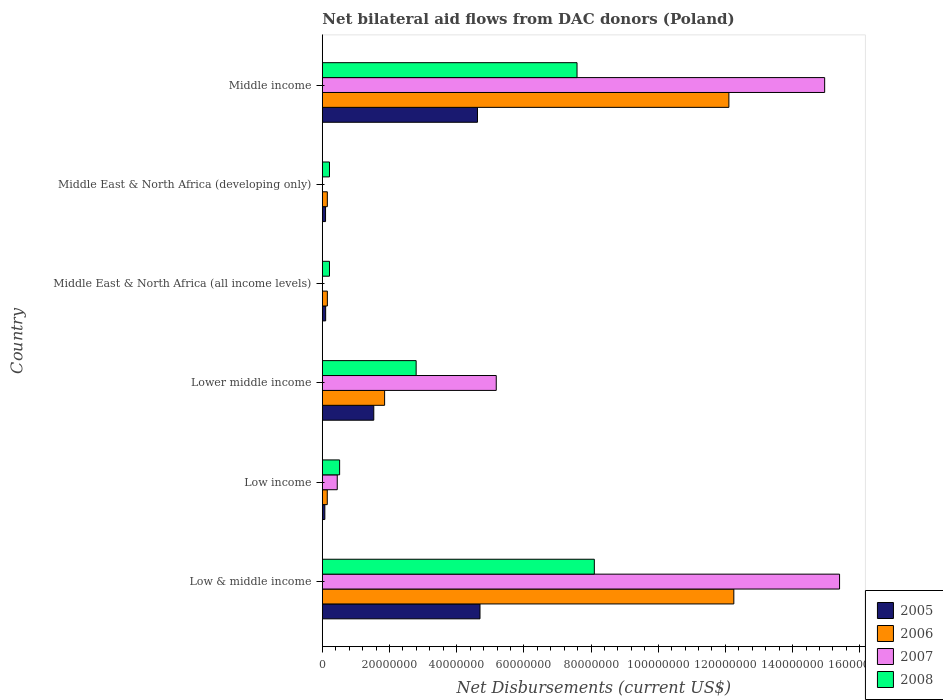How many bars are there on the 2nd tick from the top?
Provide a succinct answer. 3. In how many cases, is the number of bars for a given country not equal to the number of legend labels?
Offer a very short reply. 2. What is the net bilateral aid flows in 2005 in Low income?
Provide a short and direct response. 7.50e+05. Across all countries, what is the maximum net bilateral aid flows in 2008?
Offer a terse response. 8.10e+07. Across all countries, what is the minimum net bilateral aid flows in 2005?
Offer a terse response. 7.50e+05. What is the total net bilateral aid flows in 2008 in the graph?
Make the answer very short. 1.94e+08. What is the difference between the net bilateral aid flows in 2006 in Low income and that in Middle income?
Keep it short and to the point. -1.20e+08. What is the difference between the net bilateral aid flows in 2005 in Middle income and the net bilateral aid flows in 2006 in Low & middle income?
Provide a short and direct response. -7.63e+07. What is the average net bilateral aid flows in 2005 per country?
Provide a succinct answer. 1.85e+07. What is the difference between the net bilateral aid flows in 2008 and net bilateral aid flows in 2007 in Middle income?
Provide a short and direct response. -7.37e+07. What is the ratio of the net bilateral aid flows in 2008 in Low income to that in Middle East & North Africa (all income levels)?
Your answer should be very brief. 2.42. Is the net bilateral aid flows in 2005 in Low & middle income less than that in Low income?
Give a very brief answer. No. Is the difference between the net bilateral aid flows in 2008 in Low & middle income and Middle income greater than the difference between the net bilateral aid flows in 2007 in Low & middle income and Middle income?
Make the answer very short. Yes. What is the difference between the highest and the second highest net bilateral aid flows in 2008?
Give a very brief answer. 5.15e+06. What is the difference between the highest and the lowest net bilateral aid flows in 2008?
Give a very brief answer. 7.88e+07. Is the sum of the net bilateral aid flows in 2005 in Lower middle income and Middle East & North Africa (developing only) greater than the maximum net bilateral aid flows in 2007 across all countries?
Keep it short and to the point. No. Is it the case that in every country, the sum of the net bilateral aid flows in 2008 and net bilateral aid flows in 2007 is greater than the sum of net bilateral aid flows in 2006 and net bilateral aid flows in 2005?
Keep it short and to the point. No. Is it the case that in every country, the sum of the net bilateral aid flows in 2007 and net bilateral aid flows in 2005 is greater than the net bilateral aid flows in 2006?
Make the answer very short. No. How many bars are there?
Your answer should be very brief. 22. Are all the bars in the graph horizontal?
Ensure brevity in your answer.  Yes. How are the legend labels stacked?
Ensure brevity in your answer.  Vertical. What is the title of the graph?
Offer a very short reply. Net bilateral aid flows from DAC donors (Poland). What is the label or title of the X-axis?
Your answer should be compact. Net Disbursements (current US$). What is the label or title of the Y-axis?
Make the answer very short. Country. What is the Net Disbursements (current US$) in 2005 in Low & middle income?
Keep it short and to the point. 4.69e+07. What is the Net Disbursements (current US$) in 2006 in Low & middle income?
Your response must be concise. 1.23e+08. What is the Net Disbursements (current US$) of 2007 in Low & middle income?
Your response must be concise. 1.54e+08. What is the Net Disbursements (current US$) of 2008 in Low & middle income?
Offer a very short reply. 8.10e+07. What is the Net Disbursements (current US$) in 2005 in Low income?
Make the answer very short. 7.50e+05. What is the Net Disbursements (current US$) in 2006 in Low income?
Make the answer very short. 1.47e+06. What is the Net Disbursements (current US$) in 2007 in Low income?
Offer a very short reply. 4.44e+06. What is the Net Disbursements (current US$) in 2008 in Low income?
Offer a terse response. 5.15e+06. What is the Net Disbursements (current US$) in 2005 in Lower middle income?
Provide a succinct answer. 1.53e+07. What is the Net Disbursements (current US$) in 2006 in Lower middle income?
Offer a very short reply. 1.85e+07. What is the Net Disbursements (current US$) of 2007 in Lower middle income?
Ensure brevity in your answer.  5.18e+07. What is the Net Disbursements (current US$) in 2008 in Lower middle income?
Your answer should be compact. 2.79e+07. What is the Net Disbursements (current US$) of 2005 in Middle East & North Africa (all income levels)?
Make the answer very short. 9.90e+05. What is the Net Disbursements (current US$) in 2006 in Middle East & North Africa (all income levels)?
Make the answer very short. 1.50e+06. What is the Net Disbursements (current US$) in 2007 in Middle East & North Africa (all income levels)?
Your answer should be very brief. 0. What is the Net Disbursements (current US$) of 2008 in Middle East & North Africa (all income levels)?
Your answer should be compact. 2.13e+06. What is the Net Disbursements (current US$) in 2005 in Middle East & North Africa (developing only)?
Keep it short and to the point. 9.60e+05. What is the Net Disbursements (current US$) in 2006 in Middle East & North Africa (developing only)?
Give a very brief answer. 1.49e+06. What is the Net Disbursements (current US$) in 2008 in Middle East & North Africa (developing only)?
Offer a very short reply. 2.13e+06. What is the Net Disbursements (current US$) of 2005 in Middle income?
Keep it short and to the point. 4.62e+07. What is the Net Disbursements (current US$) in 2006 in Middle income?
Make the answer very short. 1.21e+08. What is the Net Disbursements (current US$) of 2007 in Middle income?
Keep it short and to the point. 1.50e+08. What is the Net Disbursements (current US$) in 2008 in Middle income?
Your answer should be very brief. 7.58e+07. Across all countries, what is the maximum Net Disbursements (current US$) in 2005?
Your response must be concise. 4.69e+07. Across all countries, what is the maximum Net Disbursements (current US$) in 2006?
Give a very brief answer. 1.23e+08. Across all countries, what is the maximum Net Disbursements (current US$) in 2007?
Offer a very short reply. 1.54e+08. Across all countries, what is the maximum Net Disbursements (current US$) of 2008?
Offer a terse response. 8.10e+07. Across all countries, what is the minimum Net Disbursements (current US$) of 2005?
Provide a succinct answer. 7.50e+05. Across all countries, what is the minimum Net Disbursements (current US$) in 2006?
Make the answer very short. 1.47e+06. Across all countries, what is the minimum Net Disbursements (current US$) of 2008?
Your response must be concise. 2.13e+06. What is the total Net Disbursements (current US$) of 2005 in the graph?
Give a very brief answer. 1.11e+08. What is the total Net Disbursements (current US$) in 2006 in the graph?
Your answer should be compact. 2.67e+08. What is the total Net Disbursements (current US$) in 2007 in the graph?
Your answer should be compact. 3.60e+08. What is the total Net Disbursements (current US$) in 2008 in the graph?
Make the answer very short. 1.94e+08. What is the difference between the Net Disbursements (current US$) in 2005 in Low & middle income and that in Low income?
Make the answer very short. 4.62e+07. What is the difference between the Net Disbursements (current US$) of 2006 in Low & middle income and that in Low income?
Ensure brevity in your answer.  1.21e+08. What is the difference between the Net Disbursements (current US$) in 2007 in Low & middle income and that in Low income?
Make the answer very short. 1.50e+08. What is the difference between the Net Disbursements (current US$) in 2008 in Low & middle income and that in Low income?
Offer a very short reply. 7.58e+07. What is the difference between the Net Disbursements (current US$) of 2005 in Low & middle income and that in Lower middle income?
Provide a short and direct response. 3.16e+07. What is the difference between the Net Disbursements (current US$) of 2006 in Low & middle income and that in Lower middle income?
Give a very brief answer. 1.04e+08. What is the difference between the Net Disbursements (current US$) of 2007 in Low & middle income and that in Lower middle income?
Ensure brevity in your answer.  1.02e+08. What is the difference between the Net Disbursements (current US$) in 2008 in Low & middle income and that in Lower middle income?
Your answer should be very brief. 5.30e+07. What is the difference between the Net Disbursements (current US$) in 2005 in Low & middle income and that in Middle East & North Africa (all income levels)?
Provide a short and direct response. 4.60e+07. What is the difference between the Net Disbursements (current US$) of 2006 in Low & middle income and that in Middle East & North Africa (all income levels)?
Your answer should be compact. 1.21e+08. What is the difference between the Net Disbursements (current US$) of 2008 in Low & middle income and that in Middle East & North Africa (all income levels)?
Offer a very short reply. 7.88e+07. What is the difference between the Net Disbursements (current US$) in 2005 in Low & middle income and that in Middle East & North Africa (developing only)?
Your answer should be very brief. 4.60e+07. What is the difference between the Net Disbursements (current US$) of 2006 in Low & middle income and that in Middle East & North Africa (developing only)?
Your response must be concise. 1.21e+08. What is the difference between the Net Disbursements (current US$) of 2008 in Low & middle income and that in Middle East & North Africa (developing only)?
Keep it short and to the point. 7.88e+07. What is the difference between the Net Disbursements (current US$) of 2005 in Low & middle income and that in Middle income?
Give a very brief answer. 7.50e+05. What is the difference between the Net Disbursements (current US$) in 2006 in Low & middle income and that in Middle income?
Your answer should be very brief. 1.47e+06. What is the difference between the Net Disbursements (current US$) in 2007 in Low & middle income and that in Middle income?
Your answer should be compact. 4.44e+06. What is the difference between the Net Disbursements (current US$) of 2008 in Low & middle income and that in Middle income?
Your answer should be compact. 5.15e+06. What is the difference between the Net Disbursements (current US$) in 2005 in Low income and that in Lower middle income?
Provide a short and direct response. -1.46e+07. What is the difference between the Net Disbursements (current US$) of 2006 in Low income and that in Lower middle income?
Give a very brief answer. -1.71e+07. What is the difference between the Net Disbursements (current US$) in 2007 in Low income and that in Lower middle income?
Make the answer very short. -4.73e+07. What is the difference between the Net Disbursements (current US$) of 2008 in Low income and that in Lower middle income?
Your answer should be compact. -2.28e+07. What is the difference between the Net Disbursements (current US$) of 2005 in Low income and that in Middle East & North Africa (all income levels)?
Give a very brief answer. -2.40e+05. What is the difference between the Net Disbursements (current US$) of 2008 in Low income and that in Middle East & North Africa (all income levels)?
Provide a short and direct response. 3.02e+06. What is the difference between the Net Disbursements (current US$) of 2005 in Low income and that in Middle East & North Africa (developing only)?
Give a very brief answer. -2.10e+05. What is the difference between the Net Disbursements (current US$) of 2008 in Low income and that in Middle East & North Africa (developing only)?
Offer a terse response. 3.02e+06. What is the difference between the Net Disbursements (current US$) in 2005 in Low income and that in Middle income?
Ensure brevity in your answer.  -4.54e+07. What is the difference between the Net Disbursements (current US$) in 2006 in Low income and that in Middle income?
Make the answer very short. -1.20e+08. What is the difference between the Net Disbursements (current US$) in 2007 in Low income and that in Middle income?
Your answer should be very brief. -1.45e+08. What is the difference between the Net Disbursements (current US$) in 2008 in Low income and that in Middle income?
Your response must be concise. -7.07e+07. What is the difference between the Net Disbursements (current US$) in 2005 in Lower middle income and that in Middle East & North Africa (all income levels)?
Give a very brief answer. 1.43e+07. What is the difference between the Net Disbursements (current US$) of 2006 in Lower middle income and that in Middle East & North Africa (all income levels)?
Ensure brevity in your answer.  1.70e+07. What is the difference between the Net Disbursements (current US$) in 2008 in Lower middle income and that in Middle East & North Africa (all income levels)?
Offer a terse response. 2.58e+07. What is the difference between the Net Disbursements (current US$) of 2005 in Lower middle income and that in Middle East & North Africa (developing only)?
Offer a terse response. 1.44e+07. What is the difference between the Net Disbursements (current US$) in 2006 in Lower middle income and that in Middle East & North Africa (developing only)?
Your answer should be very brief. 1.70e+07. What is the difference between the Net Disbursements (current US$) of 2008 in Lower middle income and that in Middle East & North Africa (developing only)?
Your answer should be very brief. 2.58e+07. What is the difference between the Net Disbursements (current US$) of 2005 in Lower middle income and that in Middle income?
Your answer should be compact. -3.09e+07. What is the difference between the Net Disbursements (current US$) in 2006 in Lower middle income and that in Middle income?
Your answer should be very brief. -1.02e+08. What is the difference between the Net Disbursements (current US$) of 2007 in Lower middle income and that in Middle income?
Provide a succinct answer. -9.78e+07. What is the difference between the Net Disbursements (current US$) of 2008 in Lower middle income and that in Middle income?
Provide a short and direct response. -4.79e+07. What is the difference between the Net Disbursements (current US$) in 2005 in Middle East & North Africa (all income levels) and that in Middle East & North Africa (developing only)?
Provide a succinct answer. 3.00e+04. What is the difference between the Net Disbursements (current US$) of 2006 in Middle East & North Africa (all income levels) and that in Middle East & North Africa (developing only)?
Ensure brevity in your answer.  10000. What is the difference between the Net Disbursements (current US$) in 2008 in Middle East & North Africa (all income levels) and that in Middle East & North Africa (developing only)?
Keep it short and to the point. 0. What is the difference between the Net Disbursements (current US$) in 2005 in Middle East & North Africa (all income levels) and that in Middle income?
Your answer should be very brief. -4.52e+07. What is the difference between the Net Disbursements (current US$) of 2006 in Middle East & North Africa (all income levels) and that in Middle income?
Offer a very short reply. -1.20e+08. What is the difference between the Net Disbursements (current US$) of 2008 in Middle East & North Africa (all income levels) and that in Middle income?
Your response must be concise. -7.37e+07. What is the difference between the Net Disbursements (current US$) of 2005 in Middle East & North Africa (developing only) and that in Middle income?
Ensure brevity in your answer.  -4.52e+07. What is the difference between the Net Disbursements (current US$) of 2006 in Middle East & North Africa (developing only) and that in Middle income?
Make the answer very short. -1.20e+08. What is the difference between the Net Disbursements (current US$) of 2008 in Middle East & North Africa (developing only) and that in Middle income?
Make the answer very short. -7.37e+07. What is the difference between the Net Disbursements (current US$) in 2005 in Low & middle income and the Net Disbursements (current US$) in 2006 in Low income?
Provide a short and direct response. 4.55e+07. What is the difference between the Net Disbursements (current US$) in 2005 in Low & middle income and the Net Disbursements (current US$) in 2007 in Low income?
Make the answer very short. 4.25e+07. What is the difference between the Net Disbursements (current US$) of 2005 in Low & middle income and the Net Disbursements (current US$) of 2008 in Low income?
Give a very brief answer. 4.18e+07. What is the difference between the Net Disbursements (current US$) of 2006 in Low & middle income and the Net Disbursements (current US$) of 2007 in Low income?
Provide a succinct answer. 1.18e+08. What is the difference between the Net Disbursements (current US$) of 2006 in Low & middle income and the Net Disbursements (current US$) of 2008 in Low income?
Give a very brief answer. 1.17e+08. What is the difference between the Net Disbursements (current US$) of 2007 in Low & middle income and the Net Disbursements (current US$) of 2008 in Low income?
Provide a short and direct response. 1.49e+08. What is the difference between the Net Disbursements (current US$) of 2005 in Low & middle income and the Net Disbursements (current US$) of 2006 in Lower middle income?
Offer a terse response. 2.84e+07. What is the difference between the Net Disbursements (current US$) in 2005 in Low & middle income and the Net Disbursements (current US$) in 2007 in Lower middle income?
Give a very brief answer. -4.84e+06. What is the difference between the Net Disbursements (current US$) of 2005 in Low & middle income and the Net Disbursements (current US$) of 2008 in Lower middle income?
Ensure brevity in your answer.  1.90e+07. What is the difference between the Net Disbursements (current US$) of 2006 in Low & middle income and the Net Disbursements (current US$) of 2007 in Lower middle income?
Your answer should be very brief. 7.07e+07. What is the difference between the Net Disbursements (current US$) of 2006 in Low & middle income and the Net Disbursements (current US$) of 2008 in Lower middle income?
Offer a very short reply. 9.46e+07. What is the difference between the Net Disbursements (current US$) in 2007 in Low & middle income and the Net Disbursements (current US$) in 2008 in Lower middle income?
Offer a very short reply. 1.26e+08. What is the difference between the Net Disbursements (current US$) in 2005 in Low & middle income and the Net Disbursements (current US$) in 2006 in Middle East & North Africa (all income levels)?
Your answer should be very brief. 4.54e+07. What is the difference between the Net Disbursements (current US$) of 2005 in Low & middle income and the Net Disbursements (current US$) of 2008 in Middle East & North Africa (all income levels)?
Provide a short and direct response. 4.48e+07. What is the difference between the Net Disbursements (current US$) of 2006 in Low & middle income and the Net Disbursements (current US$) of 2008 in Middle East & North Africa (all income levels)?
Offer a terse response. 1.20e+08. What is the difference between the Net Disbursements (current US$) of 2007 in Low & middle income and the Net Disbursements (current US$) of 2008 in Middle East & North Africa (all income levels)?
Keep it short and to the point. 1.52e+08. What is the difference between the Net Disbursements (current US$) of 2005 in Low & middle income and the Net Disbursements (current US$) of 2006 in Middle East & North Africa (developing only)?
Your answer should be very brief. 4.54e+07. What is the difference between the Net Disbursements (current US$) in 2005 in Low & middle income and the Net Disbursements (current US$) in 2008 in Middle East & North Africa (developing only)?
Keep it short and to the point. 4.48e+07. What is the difference between the Net Disbursements (current US$) in 2006 in Low & middle income and the Net Disbursements (current US$) in 2008 in Middle East & North Africa (developing only)?
Provide a short and direct response. 1.20e+08. What is the difference between the Net Disbursements (current US$) in 2007 in Low & middle income and the Net Disbursements (current US$) in 2008 in Middle East & North Africa (developing only)?
Your answer should be compact. 1.52e+08. What is the difference between the Net Disbursements (current US$) of 2005 in Low & middle income and the Net Disbursements (current US$) of 2006 in Middle income?
Your answer should be compact. -7.41e+07. What is the difference between the Net Disbursements (current US$) in 2005 in Low & middle income and the Net Disbursements (current US$) in 2007 in Middle income?
Offer a terse response. -1.03e+08. What is the difference between the Net Disbursements (current US$) in 2005 in Low & middle income and the Net Disbursements (current US$) in 2008 in Middle income?
Your answer should be very brief. -2.89e+07. What is the difference between the Net Disbursements (current US$) of 2006 in Low & middle income and the Net Disbursements (current US$) of 2007 in Middle income?
Offer a very short reply. -2.70e+07. What is the difference between the Net Disbursements (current US$) of 2006 in Low & middle income and the Net Disbursements (current US$) of 2008 in Middle income?
Provide a succinct answer. 4.67e+07. What is the difference between the Net Disbursements (current US$) of 2007 in Low & middle income and the Net Disbursements (current US$) of 2008 in Middle income?
Offer a very short reply. 7.82e+07. What is the difference between the Net Disbursements (current US$) of 2005 in Low income and the Net Disbursements (current US$) of 2006 in Lower middle income?
Offer a very short reply. -1.78e+07. What is the difference between the Net Disbursements (current US$) of 2005 in Low income and the Net Disbursements (current US$) of 2007 in Lower middle income?
Provide a short and direct response. -5.10e+07. What is the difference between the Net Disbursements (current US$) in 2005 in Low income and the Net Disbursements (current US$) in 2008 in Lower middle income?
Make the answer very short. -2.72e+07. What is the difference between the Net Disbursements (current US$) of 2006 in Low income and the Net Disbursements (current US$) of 2007 in Lower middle income?
Provide a short and direct response. -5.03e+07. What is the difference between the Net Disbursements (current US$) of 2006 in Low income and the Net Disbursements (current US$) of 2008 in Lower middle income?
Ensure brevity in your answer.  -2.65e+07. What is the difference between the Net Disbursements (current US$) of 2007 in Low income and the Net Disbursements (current US$) of 2008 in Lower middle income?
Your response must be concise. -2.35e+07. What is the difference between the Net Disbursements (current US$) in 2005 in Low income and the Net Disbursements (current US$) in 2006 in Middle East & North Africa (all income levels)?
Keep it short and to the point. -7.50e+05. What is the difference between the Net Disbursements (current US$) of 2005 in Low income and the Net Disbursements (current US$) of 2008 in Middle East & North Africa (all income levels)?
Your answer should be compact. -1.38e+06. What is the difference between the Net Disbursements (current US$) of 2006 in Low income and the Net Disbursements (current US$) of 2008 in Middle East & North Africa (all income levels)?
Make the answer very short. -6.60e+05. What is the difference between the Net Disbursements (current US$) of 2007 in Low income and the Net Disbursements (current US$) of 2008 in Middle East & North Africa (all income levels)?
Keep it short and to the point. 2.31e+06. What is the difference between the Net Disbursements (current US$) in 2005 in Low income and the Net Disbursements (current US$) in 2006 in Middle East & North Africa (developing only)?
Your response must be concise. -7.40e+05. What is the difference between the Net Disbursements (current US$) of 2005 in Low income and the Net Disbursements (current US$) of 2008 in Middle East & North Africa (developing only)?
Give a very brief answer. -1.38e+06. What is the difference between the Net Disbursements (current US$) in 2006 in Low income and the Net Disbursements (current US$) in 2008 in Middle East & North Africa (developing only)?
Ensure brevity in your answer.  -6.60e+05. What is the difference between the Net Disbursements (current US$) in 2007 in Low income and the Net Disbursements (current US$) in 2008 in Middle East & North Africa (developing only)?
Your answer should be very brief. 2.31e+06. What is the difference between the Net Disbursements (current US$) of 2005 in Low income and the Net Disbursements (current US$) of 2006 in Middle income?
Offer a very short reply. -1.20e+08. What is the difference between the Net Disbursements (current US$) of 2005 in Low income and the Net Disbursements (current US$) of 2007 in Middle income?
Make the answer very short. -1.49e+08. What is the difference between the Net Disbursements (current US$) of 2005 in Low income and the Net Disbursements (current US$) of 2008 in Middle income?
Offer a terse response. -7.51e+07. What is the difference between the Net Disbursements (current US$) in 2006 in Low income and the Net Disbursements (current US$) in 2007 in Middle income?
Offer a terse response. -1.48e+08. What is the difference between the Net Disbursements (current US$) of 2006 in Low income and the Net Disbursements (current US$) of 2008 in Middle income?
Provide a succinct answer. -7.44e+07. What is the difference between the Net Disbursements (current US$) of 2007 in Low income and the Net Disbursements (current US$) of 2008 in Middle income?
Provide a short and direct response. -7.14e+07. What is the difference between the Net Disbursements (current US$) in 2005 in Lower middle income and the Net Disbursements (current US$) in 2006 in Middle East & North Africa (all income levels)?
Provide a succinct answer. 1.38e+07. What is the difference between the Net Disbursements (current US$) in 2005 in Lower middle income and the Net Disbursements (current US$) in 2008 in Middle East & North Africa (all income levels)?
Keep it short and to the point. 1.32e+07. What is the difference between the Net Disbursements (current US$) in 2006 in Lower middle income and the Net Disbursements (current US$) in 2008 in Middle East & North Africa (all income levels)?
Keep it short and to the point. 1.64e+07. What is the difference between the Net Disbursements (current US$) of 2007 in Lower middle income and the Net Disbursements (current US$) of 2008 in Middle East & North Africa (all income levels)?
Offer a terse response. 4.96e+07. What is the difference between the Net Disbursements (current US$) of 2005 in Lower middle income and the Net Disbursements (current US$) of 2006 in Middle East & North Africa (developing only)?
Offer a terse response. 1.38e+07. What is the difference between the Net Disbursements (current US$) of 2005 in Lower middle income and the Net Disbursements (current US$) of 2008 in Middle East & North Africa (developing only)?
Provide a short and direct response. 1.32e+07. What is the difference between the Net Disbursements (current US$) in 2006 in Lower middle income and the Net Disbursements (current US$) in 2008 in Middle East & North Africa (developing only)?
Your answer should be compact. 1.64e+07. What is the difference between the Net Disbursements (current US$) of 2007 in Lower middle income and the Net Disbursements (current US$) of 2008 in Middle East & North Africa (developing only)?
Your answer should be very brief. 4.96e+07. What is the difference between the Net Disbursements (current US$) of 2005 in Lower middle income and the Net Disbursements (current US$) of 2006 in Middle income?
Give a very brief answer. -1.06e+08. What is the difference between the Net Disbursements (current US$) in 2005 in Lower middle income and the Net Disbursements (current US$) in 2007 in Middle income?
Your response must be concise. -1.34e+08. What is the difference between the Net Disbursements (current US$) in 2005 in Lower middle income and the Net Disbursements (current US$) in 2008 in Middle income?
Give a very brief answer. -6.05e+07. What is the difference between the Net Disbursements (current US$) of 2006 in Lower middle income and the Net Disbursements (current US$) of 2007 in Middle income?
Offer a very short reply. -1.31e+08. What is the difference between the Net Disbursements (current US$) of 2006 in Lower middle income and the Net Disbursements (current US$) of 2008 in Middle income?
Your answer should be very brief. -5.73e+07. What is the difference between the Net Disbursements (current US$) in 2007 in Lower middle income and the Net Disbursements (current US$) in 2008 in Middle income?
Make the answer very short. -2.40e+07. What is the difference between the Net Disbursements (current US$) of 2005 in Middle East & North Africa (all income levels) and the Net Disbursements (current US$) of 2006 in Middle East & North Africa (developing only)?
Your answer should be compact. -5.00e+05. What is the difference between the Net Disbursements (current US$) of 2005 in Middle East & North Africa (all income levels) and the Net Disbursements (current US$) of 2008 in Middle East & North Africa (developing only)?
Ensure brevity in your answer.  -1.14e+06. What is the difference between the Net Disbursements (current US$) in 2006 in Middle East & North Africa (all income levels) and the Net Disbursements (current US$) in 2008 in Middle East & North Africa (developing only)?
Your response must be concise. -6.30e+05. What is the difference between the Net Disbursements (current US$) in 2005 in Middle East & North Africa (all income levels) and the Net Disbursements (current US$) in 2006 in Middle income?
Offer a terse response. -1.20e+08. What is the difference between the Net Disbursements (current US$) in 2005 in Middle East & North Africa (all income levels) and the Net Disbursements (current US$) in 2007 in Middle income?
Give a very brief answer. -1.49e+08. What is the difference between the Net Disbursements (current US$) of 2005 in Middle East & North Africa (all income levels) and the Net Disbursements (current US$) of 2008 in Middle income?
Make the answer very short. -7.48e+07. What is the difference between the Net Disbursements (current US$) of 2006 in Middle East & North Africa (all income levels) and the Net Disbursements (current US$) of 2007 in Middle income?
Your response must be concise. -1.48e+08. What is the difference between the Net Disbursements (current US$) in 2006 in Middle East & North Africa (all income levels) and the Net Disbursements (current US$) in 2008 in Middle income?
Give a very brief answer. -7.43e+07. What is the difference between the Net Disbursements (current US$) in 2005 in Middle East & North Africa (developing only) and the Net Disbursements (current US$) in 2006 in Middle income?
Keep it short and to the point. -1.20e+08. What is the difference between the Net Disbursements (current US$) of 2005 in Middle East & North Africa (developing only) and the Net Disbursements (current US$) of 2007 in Middle income?
Offer a terse response. -1.49e+08. What is the difference between the Net Disbursements (current US$) of 2005 in Middle East & North Africa (developing only) and the Net Disbursements (current US$) of 2008 in Middle income?
Your answer should be very brief. -7.49e+07. What is the difference between the Net Disbursements (current US$) in 2006 in Middle East & North Africa (developing only) and the Net Disbursements (current US$) in 2007 in Middle income?
Give a very brief answer. -1.48e+08. What is the difference between the Net Disbursements (current US$) of 2006 in Middle East & North Africa (developing only) and the Net Disbursements (current US$) of 2008 in Middle income?
Keep it short and to the point. -7.43e+07. What is the average Net Disbursements (current US$) of 2005 per country?
Make the answer very short. 1.85e+07. What is the average Net Disbursements (current US$) in 2006 per country?
Make the answer very short. 4.44e+07. What is the average Net Disbursements (current US$) in 2007 per country?
Your answer should be very brief. 6.00e+07. What is the average Net Disbursements (current US$) in 2008 per country?
Keep it short and to the point. 3.24e+07. What is the difference between the Net Disbursements (current US$) of 2005 and Net Disbursements (current US$) of 2006 in Low & middle income?
Offer a very short reply. -7.56e+07. What is the difference between the Net Disbursements (current US$) in 2005 and Net Disbursements (current US$) in 2007 in Low & middle income?
Your answer should be very brief. -1.07e+08. What is the difference between the Net Disbursements (current US$) in 2005 and Net Disbursements (current US$) in 2008 in Low & middle income?
Your answer should be very brief. -3.40e+07. What is the difference between the Net Disbursements (current US$) of 2006 and Net Disbursements (current US$) of 2007 in Low & middle income?
Provide a succinct answer. -3.15e+07. What is the difference between the Net Disbursements (current US$) of 2006 and Net Disbursements (current US$) of 2008 in Low & middle income?
Provide a short and direct response. 4.15e+07. What is the difference between the Net Disbursements (current US$) of 2007 and Net Disbursements (current US$) of 2008 in Low & middle income?
Keep it short and to the point. 7.30e+07. What is the difference between the Net Disbursements (current US$) of 2005 and Net Disbursements (current US$) of 2006 in Low income?
Give a very brief answer. -7.20e+05. What is the difference between the Net Disbursements (current US$) in 2005 and Net Disbursements (current US$) in 2007 in Low income?
Your answer should be very brief. -3.69e+06. What is the difference between the Net Disbursements (current US$) of 2005 and Net Disbursements (current US$) of 2008 in Low income?
Ensure brevity in your answer.  -4.40e+06. What is the difference between the Net Disbursements (current US$) in 2006 and Net Disbursements (current US$) in 2007 in Low income?
Provide a succinct answer. -2.97e+06. What is the difference between the Net Disbursements (current US$) in 2006 and Net Disbursements (current US$) in 2008 in Low income?
Your answer should be compact. -3.68e+06. What is the difference between the Net Disbursements (current US$) of 2007 and Net Disbursements (current US$) of 2008 in Low income?
Give a very brief answer. -7.10e+05. What is the difference between the Net Disbursements (current US$) of 2005 and Net Disbursements (current US$) of 2006 in Lower middle income?
Provide a succinct answer. -3.22e+06. What is the difference between the Net Disbursements (current US$) in 2005 and Net Disbursements (current US$) in 2007 in Lower middle income?
Ensure brevity in your answer.  -3.65e+07. What is the difference between the Net Disbursements (current US$) of 2005 and Net Disbursements (current US$) of 2008 in Lower middle income?
Keep it short and to the point. -1.26e+07. What is the difference between the Net Disbursements (current US$) in 2006 and Net Disbursements (current US$) in 2007 in Lower middle income?
Ensure brevity in your answer.  -3.32e+07. What is the difference between the Net Disbursements (current US$) in 2006 and Net Disbursements (current US$) in 2008 in Lower middle income?
Offer a very short reply. -9.39e+06. What is the difference between the Net Disbursements (current US$) in 2007 and Net Disbursements (current US$) in 2008 in Lower middle income?
Your response must be concise. 2.38e+07. What is the difference between the Net Disbursements (current US$) in 2005 and Net Disbursements (current US$) in 2006 in Middle East & North Africa (all income levels)?
Offer a very short reply. -5.10e+05. What is the difference between the Net Disbursements (current US$) in 2005 and Net Disbursements (current US$) in 2008 in Middle East & North Africa (all income levels)?
Your answer should be very brief. -1.14e+06. What is the difference between the Net Disbursements (current US$) in 2006 and Net Disbursements (current US$) in 2008 in Middle East & North Africa (all income levels)?
Ensure brevity in your answer.  -6.30e+05. What is the difference between the Net Disbursements (current US$) in 2005 and Net Disbursements (current US$) in 2006 in Middle East & North Africa (developing only)?
Provide a succinct answer. -5.30e+05. What is the difference between the Net Disbursements (current US$) of 2005 and Net Disbursements (current US$) of 2008 in Middle East & North Africa (developing only)?
Offer a terse response. -1.17e+06. What is the difference between the Net Disbursements (current US$) in 2006 and Net Disbursements (current US$) in 2008 in Middle East & North Africa (developing only)?
Make the answer very short. -6.40e+05. What is the difference between the Net Disbursements (current US$) in 2005 and Net Disbursements (current US$) in 2006 in Middle income?
Make the answer very short. -7.48e+07. What is the difference between the Net Disbursements (current US$) of 2005 and Net Disbursements (current US$) of 2007 in Middle income?
Provide a short and direct response. -1.03e+08. What is the difference between the Net Disbursements (current US$) in 2005 and Net Disbursements (current US$) in 2008 in Middle income?
Make the answer very short. -2.96e+07. What is the difference between the Net Disbursements (current US$) in 2006 and Net Disbursements (current US$) in 2007 in Middle income?
Offer a very short reply. -2.85e+07. What is the difference between the Net Disbursements (current US$) in 2006 and Net Disbursements (current US$) in 2008 in Middle income?
Your answer should be compact. 4.52e+07. What is the difference between the Net Disbursements (current US$) of 2007 and Net Disbursements (current US$) of 2008 in Middle income?
Keep it short and to the point. 7.37e+07. What is the ratio of the Net Disbursements (current US$) in 2005 in Low & middle income to that in Low income?
Your answer should be very brief. 62.59. What is the ratio of the Net Disbursements (current US$) in 2006 in Low & middle income to that in Low income?
Your answer should be compact. 83.34. What is the ratio of the Net Disbursements (current US$) in 2007 in Low & middle income to that in Low income?
Provide a succinct answer. 34.68. What is the ratio of the Net Disbursements (current US$) in 2008 in Low & middle income to that in Low income?
Give a very brief answer. 15.72. What is the ratio of the Net Disbursements (current US$) in 2005 in Low & middle income to that in Lower middle income?
Ensure brevity in your answer.  3.06. What is the ratio of the Net Disbursements (current US$) in 2006 in Low & middle income to that in Lower middle income?
Give a very brief answer. 6.61. What is the ratio of the Net Disbursements (current US$) of 2007 in Low & middle income to that in Lower middle income?
Offer a terse response. 2.97. What is the ratio of the Net Disbursements (current US$) in 2008 in Low & middle income to that in Lower middle income?
Provide a succinct answer. 2.9. What is the ratio of the Net Disbursements (current US$) in 2005 in Low & middle income to that in Middle East & North Africa (all income levels)?
Your answer should be compact. 47.41. What is the ratio of the Net Disbursements (current US$) of 2006 in Low & middle income to that in Middle East & North Africa (all income levels)?
Keep it short and to the point. 81.67. What is the ratio of the Net Disbursements (current US$) of 2008 in Low & middle income to that in Middle East & North Africa (all income levels)?
Give a very brief answer. 38.02. What is the ratio of the Net Disbursements (current US$) of 2005 in Low & middle income to that in Middle East & North Africa (developing only)?
Your answer should be very brief. 48.9. What is the ratio of the Net Disbursements (current US$) of 2006 in Low & middle income to that in Middle East & North Africa (developing only)?
Offer a terse response. 82.22. What is the ratio of the Net Disbursements (current US$) in 2008 in Low & middle income to that in Middle East & North Africa (developing only)?
Your response must be concise. 38.02. What is the ratio of the Net Disbursements (current US$) in 2005 in Low & middle income to that in Middle income?
Your response must be concise. 1.02. What is the ratio of the Net Disbursements (current US$) in 2006 in Low & middle income to that in Middle income?
Your response must be concise. 1.01. What is the ratio of the Net Disbursements (current US$) of 2007 in Low & middle income to that in Middle income?
Your answer should be very brief. 1.03. What is the ratio of the Net Disbursements (current US$) in 2008 in Low & middle income to that in Middle income?
Give a very brief answer. 1.07. What is the ratio of the Net Disbursements (current US$) of 2005 in Low income to that in Lower middle income?
Offer a terse response. 0.05. What is the ratio of the Net Disbursements (current US$) of 2006 in Low income to that in Lower middle income?
Ensure brevity in your answer.  0.08. What is the ratio of the Net Disbursements (current US$) in 2007 in Low income to that in Lower middle income?
Ensure brevity in your answer.  0.09. What is the ratio of the Net Disbursements (current US$) in 2008 in Low income to that in Lower middle income?
Give a very brief answer. 0.18. What is the ratio of the Net Disbursements (current US$) of 2005 in Low income to that in Middle East & North Africa (all income levels)?
Keep it short and to the point. 0.76. What is the ratio of the Net Disbursements (current US$) in 2006 in Low income to that in Middle East & North Africa (all income levels)?
Provide a short and direct response. 0.98. What is the ratio of the Net Disbursements (current US$) of 2008 in Low income to that in Middle East & North Africa (all income levels)?
Keep it short and to the point. 2.42. What is the ratio of the Net Disbursements (current US$) in 2005 in Low income to that in Middle East & North Africa (developing only)?
Give a very brief answer. 0.78. What is the ratio of the Net Disbursements (current US$) in 2006 in Low income to that in Middle East & North Africa (developing only)?
Your response must be concise. 0.99. What is the ratio of the Net Disbursements (current US$) of 2008 in Low income to that in Middle East & North Africa (developing only)?
Ensure brevity in your answer.  2.42. What is the ratio of the Net Disbursements (current US$) in 2005 in Low income to that in Middle income?
Keep it short and to the point. 0.02. What is the ratio of the Net Disbursements (current US$) in 2006 in Low income to that in Middle income?
Keep it short and to the point. 0.01. What is the ratio of the Net Disbursements (current US$) in 2007 in Low income to that in Middle income?
Give a very brief answer. 0.03. What is the ratio of the Net Disbursements (current US$) of 2008 in Low income to that in Middle income?
Give a very brief answer. 0.07. What is the ratio of the Net Disbursements (current US$) in 2005 in Lower middle income to that in Middle East & North Africa (all income levels)?
Your answer should be very brief. 15.47. What is the ratio of the Net Disbursements (current US$) of 2006 in Lower middle income to that in Middle East & North Africa (all income levels)?
Make the answer very short. 12.36. What is the ratio of the Net Disbursements (current US$) of 2008 in Lower middle income to that in Middle East & North Africa (all income levels)?
Offer a terse response. 13.11. What is the ratio of the Net Disbursements (current US$) of 2005 in Lower middle income to that in Middle East & North Africa (developing only)?
Offer a terse response. 15.96. What is the ratio of the Net Disbursements (current US$) in 2006 in Lower middle income to that in Middle East & North Africa (developing only)?
Make the answer very short. 12.44. What is the ratio of the Net Disbursements (current US$) of 2008 in Lower middle income to that in Middle East & North Africa (developing only)?
Offer a terse response. 13.11. What is the ratio of the Net Disbursements (current US$) in 2005 in Lower middle income to that in Middle income?
Offer a very short reply. 0.33. What is the ratio of the Net Disbursements (current US$) of 2006 in Lower middle income to that in Middle income?
Your answer should be compact. 0.15. What is the ratio of the Net Disbursements (current US$) in 2007 in Lower middle income to that in Middle income?
Offer a terse response. 0.35. What is the ratio of the Net Disbursements (current US$) in 2008 in Lower middle income to that in Middle income?
Give a very brief answer. 0.37. What is the ratio of the Net Disbursements (current US$) of 2005 in Middle East & North Africa (all income levels) to that in Middle East & North Africa (developing only)?
Offer a terse response. 1.03. What is the ratio of the Net Disbursements (current US$) of 2006 in Middle East & North Africa (all income levels) to that in Middle East & North Africa (developing only)?
Offer a terse response. 1.01. What is the ratio of the Net Disbursements (current US$) of 2008 in Middle East & North Africa (all income levels) to that in Middle East & North Africa (developing only)?
Give a very brief answer. 1. What is the ratio of the Net Disbursements (current US$) of 2005 in Middle East & North Africa (all income levels) to that in Middle income?
Provide a succinct answer. 0.02. What is the ratio of the Net Disbursements (current US$) in 2006 in Middle East & North Africa (all income levels) to that in Middle income?
Ensure brevity in your answer.  0.01. What is the ratio of the Net Disbursements (current US$) of 2008 in Middle East & North Africa (all income levels) to that in Middle income?
Your answer should be compact. 0.03. What is the ratio of the Net Disbursements (current US$) of 2005 in Middle East & North Africa (developing only) to that in Middle income?
Provide a short and direct response. 0.02. What is the ratio of the Net Disbursements (current US$) of 2006 in Middle East & North Africa (developing only) to that in Middle income?
Provide a short and direct response. 0.01. What is the ratio of the Net Disbursements (current US$) of 2008 in Middle East & North Africa (developing only) to that in Middle income?
Offer a very short reply. 0.03. What is the difference between the highest and the second highest Net Disbursements (current US$) of 2005?
Your answer should be compact. 7.50e+05. What is the difference between the highest and the second highest Net Disbursements (current US$) of 2006?
Your answer should be very brief. 1.47e+06. What is the difference between the highest and the second highest Net Disbursements (current US$) of 2007?
Your answer should be very brief. 4.44e+06. What is the difference between the highest and the second highest Net Disbursements (current US$) in 2008?
Your answer should be very brief. 5.15e+06. What is the difference between the highest and the lowest Net Disbursements (current US$) in 2005?
Give a very brief answer. 4.62e+07. What is the difference between the highest and the lowest Net Disbursements (current US$) of 2006?
Provide a short and direct response. 1.21e+08. What is the difference between the highest and the lowest Net Disbursements (current US$) in 2007?
Your answer should be very brief. 1.54e+08. What is the difference between the highest and the lowest Net Disbursements (current US$) in 2008?
Ensure brevity in your answer.  7.88e+07. 